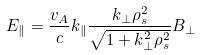Convert formula to latex. <formula><loc_0><loc_0><loc_500><loc_500>E _ { \| } = \frac { v _ { A } } { c } k _ { \| } \frac { k _ { \perp } \rho _ { s } ^ { 2 } } { \sqrt { 1 + k _ { \perp } ^ { 2 } \rho _ { s } ^ { 2 } } } B _ { \perp }</formula> 